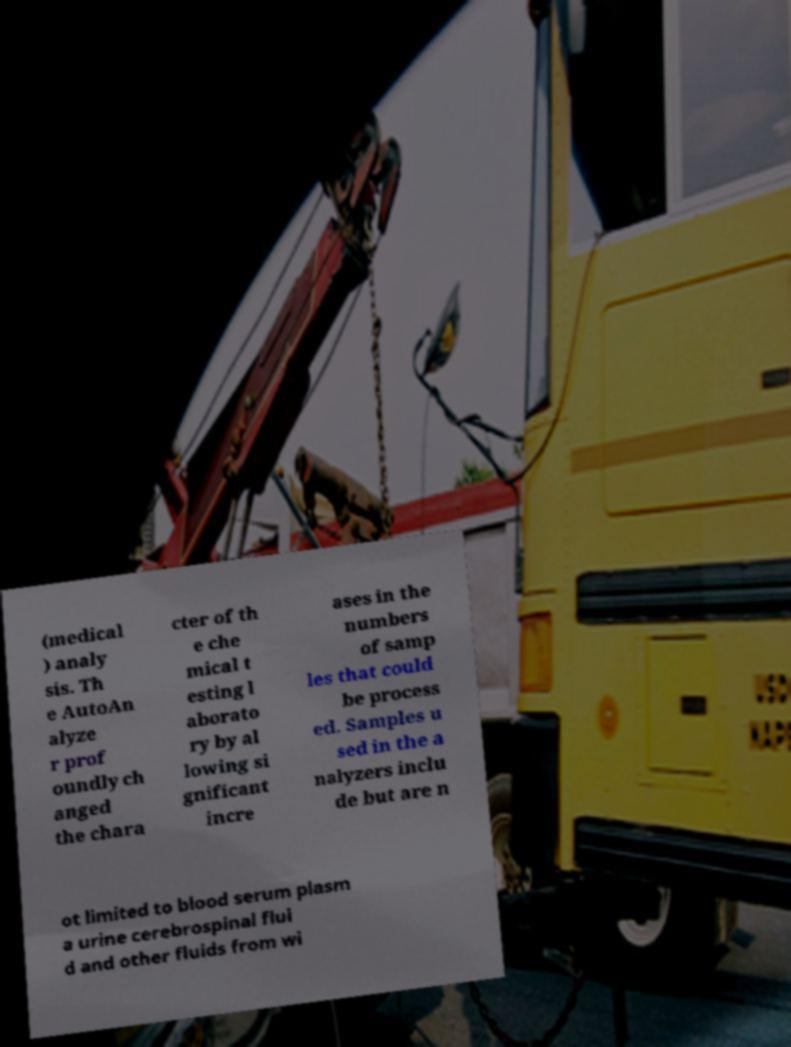Could you assist in decoding the text presented in this image and type it out clearly? (medical ) analy sis. Th e AutoAn alyze r prof oundly ch anged the chara cter of th e che mical t esting l aborato ry by al lowing si gnificant incre ases in the numbers of samp les that could be process ed. Samples u sed in the a nalyzers inclu de but are n ot limited to blood serum plasm a urine cerebrospinal flui d and other fluids from wi 